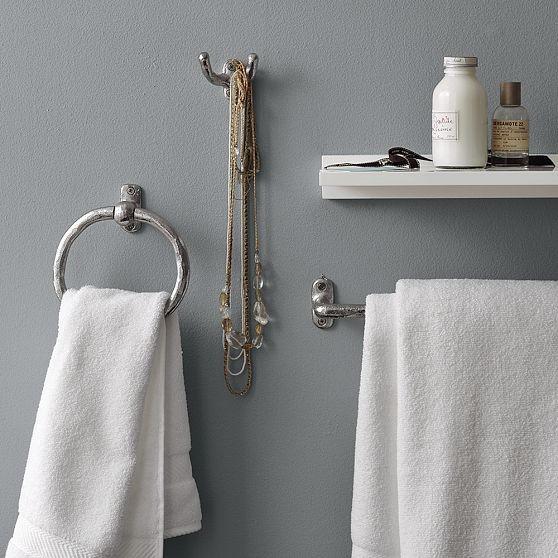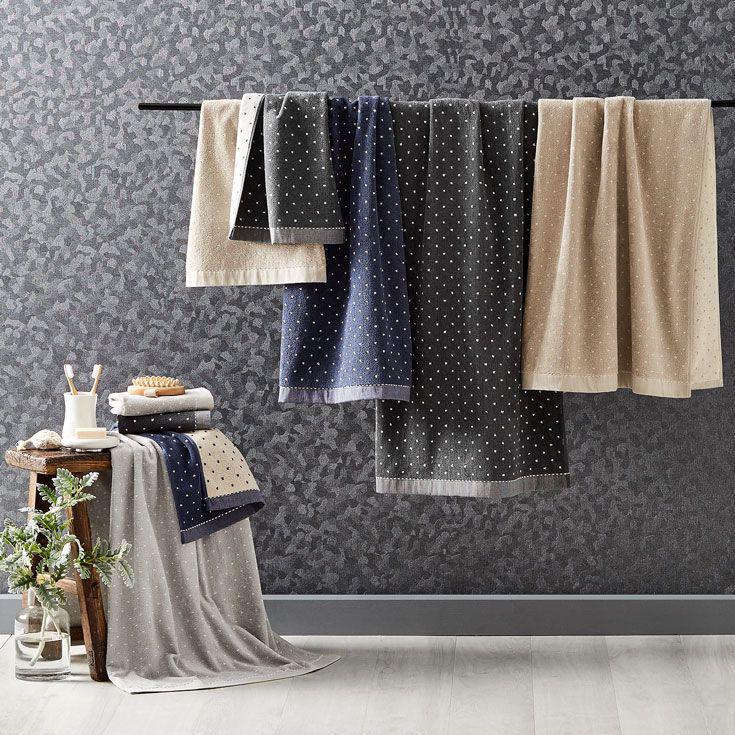The first image is the image on the left, the second image is the image on the right. Examine the images to the left and right. Is the description "An equal number of towels is hanging in each image." accurate? Answer yes or no. No. 